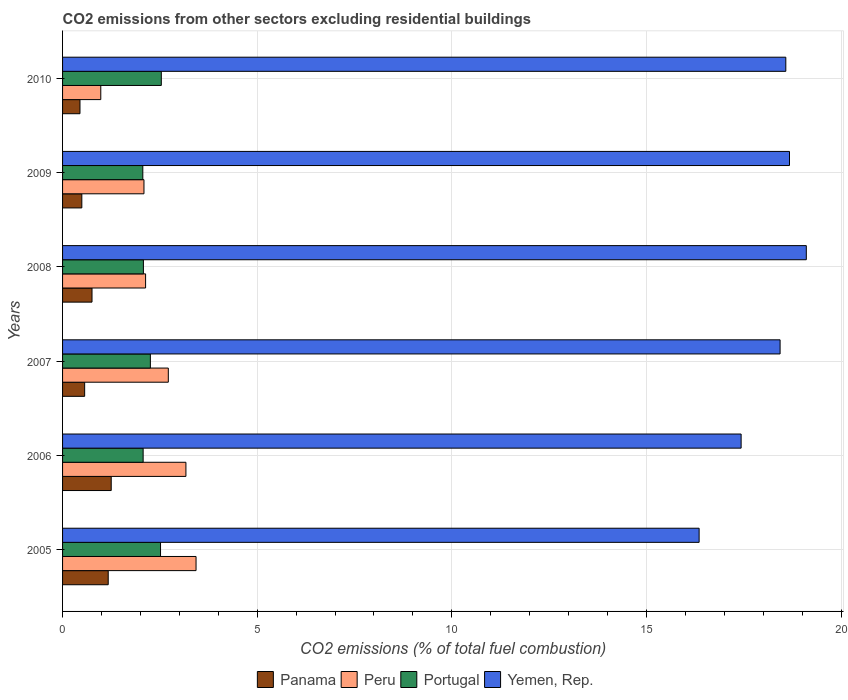How many groups of bars are there?
Ensure brevity in your answer.  6. How many bars are there on the 6th tick from the bottom?
Your answer should be compact. 4. What is the total CO2 emitted in Panama in 2006?
Provide a short and direct response. 1.25. Across all years, what is the maximum total CO2 emitted in Panama?
Your answer should be compact. 1.25. Across all years, what is the minimum total CO2 emitted in Portugal?
Give a very brief answer. 2.06. In which year was the total CO2 emitted in Yemen, Rep. minimum?
Make the answer very short. 2005. What is the total total CO2 emitted in Yemen, Rep. in the graph?
Give a very brief answer. 108.59. What is the difference between the total CO2 emitted in Yemen, Rep. in 2006 and that in 2010?
Your response must be concise. -1.15. What is the difference between the total CO2 emitted in Peru in 2006 and the total CO2 emitted in Portugal in 2010?
Offer a very short reply. 0.63. What is the average total CO2 emitted in Panama per year?
Make the answer very short. 0.78. In the year 2007, what is the difference between the total CO2 emitted in Peru and total CO2 emitted in Panama?
Your response must be concise. 2.15. What is the ratio of the total CO2 emitted in Yemen, Rep. in 2006 to that in 2010?
Your answer should be very brief. 0.94. Is the difference between the total CO2 emitted in Peru in 2007 and 2008 greater than the difference between the total CO2 emitted in Panama in 2007 and 2008?
Provide a succinct answer. Yes. What is the difference between the highest and the second highest total CO2 emitted in Portugal?
Your answer should be very brief. 0.02. What is the difference between the highest and the lowest total CO2 emitted in Portugal?
Provide a short and direct response. 0.48. Is it the case that in every year, the sum of the total CO2 emitted in Portugal and total CO2 emitted in Peru is greater than the sum of total CO2 emitted in Panama and total CO2 emitted in Yemen, Rep.?
Make the answer very short. Yes. What does the 1st bar from the top in 2010 represents?
Your answer should be very brief. Yemen, Rep. What does the 2nd bar from the bottom in 2006 represents?
Provide a short and direct response. Peru. How many bars are there?
Provide a succinct answer. 24. What is the difference between two consecutive major ticks on the X-axis?
Provide a succinct answer. 5. Does the graph contain grids?
Keep it short and to the point. Yes. How are the legend labels stacked?
Give a very brief answer. Horizontal. What is the title of the graph?
Offer a terse response. CO2 emissions from other sectors excluding residential buildings. What is the label or title of the X-axis?
Offer a very short reply. CO2 emissions (% of total fuel combustion). What is the CO2 emissions (% of total fuel combustion) in Panama in 2005?
Provide a short and direct response. 1.17. What is the CO2 emissions (% of total fuel combustion) of Peru in 2005?
Keep it short and to the point. 3.43. What is the CO2 emissions (% of total fuel combustion) in Portugal in 2005?
Make the answer very short. 2.52. What is the CO2 emissions (% of total fuel combustion) in Yemen, Rep. in 2005?
Ensure brevity in your answer.  16.35. What is the CO2 emissions (% of total fuel combustion) of Peru in 2006?
Make the answer very short. 3.17. What is the CO2 emissions (% of total fuel combustion) of Portugal in 2006?
Your answer should be compact. 2.07. What is the CO2 emissions (% of total fuel combustion) of Yemen, Rep. in 2006?
Your answer should be compact. 17.43. What is the CO2 emissions (% of total fuel combustion) of Panama in 2007?
Provide a short and direct response. 0.57. What is the CO2 emissions (% of total fuel combustion) in Peru in 2007?
Your answer should be very brief. 2.72. What is the CO2 emissions (% of total fuel combustion) of Portugal in 2007?
Keep it short and to the point. 2.26. What is the CO2 emissions (% of total fuel combustion) in Yemen, Rep. in 2007?
Make the answer very short. 18.43. What is the CO2 emissions (% of total fuel combustion) of Panama in 2008?
Provide a succinct answer. 0.76. What is the CO2 emissions (% of total fuel combustion) in Peru in 2008?
Provide a short and direct response. 2.13. What is the CO2 emissions (% of total fuel combustion) of Portugal in 2008?
Provide a succinct answer. 2.08. What is the CO2 emissions (% of total fuel combustion) in Yemen, Rep. in 2008?
Keep it short and to the point. 19.11. What is the CO2 emissions (% of total fuel combustion) of Panama in 2009?
Your answer should be very brief. 0.5. What is the CO2 emissions (% of total fuel combustion) in Peru in 2009?
Provide a succinct answer. 2.09. What is the CO2 emissions (% of total fuel combustion) in Portugal in 2009?
Keep it short and to the point. 2.06. What is the CO2 emissions (% of total fuel combustion) of Yemen, Rep. in 2009?
Your answer should be very brief. 18.68. What is the CO2 emissions (% of total fuel combustion) of Panama in 2010?
Provide a short and direct response. 0.45. What is the CO2 emissions (% of total fuel combustion) in Peru in 2010?
Your answer should be compact. 0.98. What is the CO2 emissions (% of total fuel combustion) of Portugal in 2010?
Offer a very short reply. 2.54. What is the CO2 emissions (% of total fuel combustion) of Yemen, Rep. in 2010?
Offer a terse response. 18.58. Across all years, what is the maximum CO2 emissions (% of total fuel combustion) of Peru?
Make the answer very short. 3.43. Across all years, what is the maximum CO2 emissions (% of total fuel combustion) in Portugal?
Your answer should be compact. 2.54. Across all years, what is the maximum CO2 emissions (% of total fuel combustion) in Yemen, Rep.?
Your answer should be compact. 19.11. Across all years, what is the minimum CO2 emissions (% of total fuel combustion) of Panama?
Provide a succinct answer. 0.45. Across all years, what is the minimum CO2 emissions (% of total fuel combustion) in Peru?
Ensure brevity in your answer.  0.98. Across all years, what is the minimum CO2 emissions (% of total fuel combustion) of Portugal?
Provide a short and direct response. 2.06. Across all years, what is the minimum CO2 emissions (% of total fuel combustion) in Yemen, Rep.?
Provide a succinct answer. 16.35. What is the total CO2 emissions (% of total fuel combustion) of Panama in the graph?
Ensure brevity in your answer.  4.69. What is the total CO2 emissions (% of total fuel combustion) in Peru in the graph?
Provide a short and direct response. 14.52. What is the total CO2 emissions (% of total fuel combustion) of Portugal in the graph?
Your response must be concise. 13.52. What is the total CO2 emissions (% of total fuel combustion) of Yemen, Rep. in the graph?
Offer a very short reply. 108.59. What is the difference between the CO2 emissions (% of total fuel combustion) of Panama in 2005 and that in 2006?
Make the answer very short. -0.08. What is the difference between the CO2 emissions (% of total fuel combustion) of Peru in 2005 and that in 2006?
Your response must be concise. 0.26. What is the difference between the CO2 emissions (% of total fuel combustion) of Portugal in 2005 and that in 2006?
Offer a terse response. 0.45. What is the difference between the CO2 emissions (% of total fuel combustion) of Yemen, Rep. in 2005 and that in 2006?
Your response must be concise. -1.08. What is the difference between the CO2 emissions (% of total fuel combustion) in Panama in 2005 and that in 2007?
Offer a terse response. 0.61. What is the difference between the CO2 emissions (% of total fuel combustion) of Peru in 2005 and that in 2007?
Provide a succinct answer. 0.71. What is the difference between the CO2 emissions (% of total fuel combustion) of Portugal in 2005 and that in 2007?
Provide a short and direct response. 0.26. What is the difference between the CO2 emissions (% of total fuel combustion) of Yemen, Rep. in 2005 and that in 2007?
Offer a terse response. -2.08. What is the difference between the CO2 emissions (% of total fuel combustion) of Panama in 2005 and that in 2008?
Give a very brief answer. 0.42. What is the difference between the CO2 emissions (% of total fuel combustion) of Peru in 2005 and that in 2008?
Make the answer very short. 1.3. What is the difference between the CO2 emissions (% of total fuel combustion) in Portugal in 2005 and that in 2008?
Ensure brevity in your answer.  0.44. What is the difference between the CO2 emissions (% of total fuel combustion) of Yemen, Rep. in 2005 and that in 2008?
Offer a very short reply. -2.75. What is the difference between the CO2 emissions (% of total fuel combustion) in Panama in 2005 and that in 2009?
Offer a very short reply. 0.68. What is the difference between the CO2 emissions (% of total fuel combustion) of Peru in 2005 and that in 2009?
Your response must be concise. 1.34. What is the difference between the CO2 emissions (% of total fuel combustion) of Portugal in 2005 and that in 2009?
Offer a terse response. 0.46. What is the difference between the CO2 emissions (% of total fuel combustion) of Yemen, Rep. in 2005 and that in 2009?
Ensure brevity in your answer.  -2.32. What is the difference between the CO2 emissions (% of total fuel combustion) in Panama in 2005 and that in 2010?
Offer a very short reply. 0.73. What is the difference between the CO2 emissions (% of total fuel combustion) of Peru in 2005 and that in 2010?
Provide a short and direct response. 2.45. What is the difference between the CO2 emissions (% of total fuel combustion) of Portugal in 2005 and that in 2010?
Provide a short and direct response. -0.02. What is the difference between the CO2 emissions (% of total fuel combustion) of Yemen, Rep. in 2005 and that in 2010?
Offer a terse response. -2.23. What is the difference between the CO2 emissions (% of total fuel combustion) in Panama in 2006 and that in 2007?
Your answer should be compact. 0.68. What is the difference between the CO2 emissions (% of total fuel combustion) in Peru in 2006 and that in 2007?
Give a very brief answer. 0.45. What is the difference between the CO2 emissions (% of total fuel combustion) in Portugal in 2006 and that in 2007?
Give a very brief answer. -0.19. What is the difference between the CO2 emissions (% of total fuel combustion) of Yemen, Rep. in 2006 and that in 2007?
Your response must be concise. -1. What is the difference between the CO2 emissions (% of total fuel combustion) of Panama in 2006 and that in 2008?
Ensure brevity in your answer.  0.49. What is the difference between the CO2 emissions (% of total fuel combustion) of Peru in 2006 and that in 2008?
Give a very brief answer. 1.04. What is the difference between the CO2 emissions (% of total fuel combustion) in Portugal in 2006 and that in 2008?
Give a very brief answer. -0.01. What is the difference between the CO2 emissions (% of total fuel combustion) in Yemen, Rep. in 2006 and that in 2008?
Keep it short and to the point. -1.67. What is the difference between the CO2 emissions (% of total fuel combustion) in Panama in 2006 and that in 2009?
Offer a very short reply. 0.76. What is the difference between the CO2 emissions (% of total fuel combustion) of Peru in 2006 and that in 2009?
Your answer should be compact. 1.08. What is the difference between the CO2 emissions (% of total fuel combustion) in Portugal in 2006 and that in 2009?
Make the answer very short. 0.01. What is the difference between the CO2 emissions (% of total fuel combustion) of Yemen, Rep. in 2006 and that in 2009?
Offer a terse response. -1.24. What is the difference between the CO2 emissions (% of total fuel combustion) in Panama in 2006 and that in 2010?
Offer a very short reply. 0.8. What is the difference between the CO2 emissions (% of total fuel combustion) in Peru in 2006 and that in 2010?
Your answer should be compact. 2.19. What is the difference between the CO2 emissions (% of total fuel combustion) in Portugal in 2006 and that in 2010?
Provide a succinct answer. -0.47. What is the difference between the CO2 emissions (% of total fuel combustion) of Yemen, Rep. in 2006 and that in 2010?
Offer a very short reply. -1.15. What is the difference between the CO2 emissions (% of total fuel combustion) in Panama in 2007 and that in 2008?
Provide a succinct answer. -0.19. What is the difference between the CO2 emissions (% of total fuel combustion) in Peru in 2007 and that in 2008?
Ensure brevity in your answer.  0.58. What is the difference between the CO2 emissions (% of total fuel combustion) of Portugal in 2007 and that in 2008?
Provide a succinct answer. 0.18. What is the difference between the CO2 emissions (% of total fuel combustion) in Yemen, Rep. in 2007 and that in 2008?
Your answer should be very brief. -0.67. What is the difference between the CO2 emissions (% of total fuel combustion) of Panama in 2007 and that in 2009?
Ensure brevity in your answer.  0.07. What is the difference between the CO2 emissions (% of total fuel combustion) in Peru in 2007 and that in 2009?
Your response must be concise. 0.63. What is the difference between the CO2 emissions (% of total fuel combustion) of Portugal in 2007 and that in 2009?
Offer a very short reply. 0.19. What is the difference between the CO2 emissions (% of total fuel combustion) of Yemen, Rep. in 2007 and that in 2009?
Your answer should be very brief. -0.24. What is the difference between the CO2 emissions (% of total fuel combustion) in Panama in 2007 and that in 2010?
Your response must be concise. 0.12. What is the difference between the CO2 emissions (% of total fuel combustion) in Peru in 2007 and that in 2010?
Provide a succinct answer. 1.73. What is the difference between the CO2 emissions (% of total fuel combustion) in Portugal in 2007 and that in 2010?
Provide a succinct answer. -0.28. What is the difference between the CO2 emissions (% of total fuel combustion) of Yemen, Rep. in 2007 and that in 2010?
Your answer should be compact. -0.15. What is the difference between the CO2 emissions (% of total fuel combustion) in Panama in 2008 and that in 2009?
Ensure brevity in your answer.  0.26. What is the difference between the CO2 emissions (% of total fuel combustion) in Peru in 2008 and that in 2009?
Ensure brevity in your answer.  0.04. What is the difference between the CO2 emissions (% of total fuel combustion) of Portugal in 2008 and that in 2009?
Your answer should be compact. 0.02. What is the difference between the CO2 emissions (% of total fuel combustion) in Yemen, Rep. in 2008 and that in 2009?
Keep it short and to the point. 0.43. What is the difference between the CO2 emissions (% of total fuel combustion) in Panama in 2008 and that in 2010?
Offer a terse response. 0.31. What is the difference between the CO2 emissions (% of total fuel combustion) in Peru in 2008 and that in 2010?
Your answer should be very brief. 1.15. What is the difference between the CO2 emissions (% of total fuel combustion) of Portugal in 2008 and that in 2010?
Give a very brief answer. -0.46. What is the difference between the CO2 emissions (% of total fuel combustion) in Yemen, Rep. in 2008 and that in 2010?
Keep it short and to the point. 0.53. What is the difference between the CO2 emissions (% of total fuel combustion) in Panama in 2009 and that in 2010?
Provide a succinct answer. 0.05. What is the difference between the CO2 emissions (% of total fuel combustion) of Peru in 2009 and that in 2010?
Your answer should be very brief. 1.11. What is the difference between the CO2 emissions (% of total fuel combustion) in Portugal in 2009 and that in 2010?
Provide a succinct answer. -0.48. What is the difference between the CO2 emissions (% of total fuel combustion) of Yemen, Rep. in 2009 and that in 2010?
Keep it short and to the point. 0.09. What is the difference between the CO2 emissions (% of total fuel combustion) of Panama in 2005 and the CO2 emissions (% of total fuel combustion) of Peru in 2006?
Make the answer very short. -2. What is the difference between the CO2 emissions (% of total fuel combustion) in Panama in 2005 and the CO2 emissions (% of total fuel combustion) in Portugal in 2006?
Your answer should be very brief. -0.9. What is the difference between the CO2 emissions (% of total fuel combustion) in Panama in 2005 and the CO2 emissions (% of total fuel combustion) in Yemen, Rep. in 2006?
Give a very brief answer. -16.26. What is the difference between the CO2 emissions (% of total fuel combustion) in Peru in 2005 and the CO2 emissions (% of total fuel combustion) in Portugal in 2006?
Make the answer very short. 1.36. What is the difference between the CO2 emissions (% of total fuel combustion) in Peru in 2005 and the CO2 emissions (% of total fuel combustion) in Yemen, Rep. in 2006?
Offer a very short reply. -14. What is the difference between the CO2 emissions (% of total fuel combustion) of Portugal in 2005 and the CO2 emissions (% of total fuel combustion) of Yemen, Rep. in 2006?
Your response must be concise. -14.92. What is the difference between the CO2 emissions (% of total fuel combustion) of Panama in 2005 and the CO2 emissions (% of total fuel combustion) of Peru in 2007?
Provide a succinct answer. -1.54. What is the difference between the CO2 emissions (% of total fuel combustion) of Panama in 2005 and the CO2 emissions (% of total fuel combustion) of Portugal in 2007?
Your answer should be compact. -1.08. What is the difference between the CO2 emissions (% of total fuel combustion) in Panama in 2005 and the CO2 emissions (% of total fuel combustion) in Yemen, Rep. in 2007?
Provide a succinct answer. -17.26. What is the difference between the CO2 emissions (% of total fuel combustion) in Peru in 2005 and the CO2 emissions (% of total fuel combustion) in Portugal in 2007?
Keep it short and to the point. 1.17. What is the difference between the CO2 emissions (% of total fuel combustion) in Peru in 2005 and the CO2 emissions (% of total fuel combustion) in Yemen, Rep. in 2007?
Your answer should be very brief. -15.01. What is the difference between the CO2 emissions (% of total fuel combustion) in Portugal in 2005 and the CO2 emissions (% of total fuel combustion) in Yemen, Rep. in 2007?
Give a very brief answer. -15.92. What is the difference between the CO2 emissions (% of total fuel combustion) of Panama in 2005 and the CO2 emissions (% of total fuel combustion) of Peru in 2008?
Ensure brevity in your answer.  -0.96. What is the difference between the CO2 emissions (% of total fuel combustion) of Panama in 2005 and the CO2 emissions (% of total fuel combustion) of Portugal in 2008?
Ensure brevity in your answer.  -0.9. What is the difference between the CO2 emissions (% of total fuel combustion) in Panama in 2005 and the CO2 emissions (% of total fuel combustion) in Yemen, Rep. in 2008?
Your answer should be compact. -17.93. What is the difference between the CO2 emissions (% of total fuel combustion) of Peru in 2005 and the CO2 emissions (% of total fuel combustion) of Portugal in 2008?
Your response must be concise. 1.35. What is the difference between the CO2 emissions (% of total fuel combustion) of Peru in 2005 and the CO2 emissions (% of total fuel combustion) of Yemen, Rep. in 2008?
Provide a short and direct response. -15.68. What is the difference between the CO2 emissions (% of total fuel combustion) of Portugal in 2005 and the CO2 emissions (% of total fuel combustion) of Yemen, Rep. in 2008?
Your answer should be compact. -16.59. What is the difference between the CO2 emissions (% of total fuel combustion) in Panama in 2005 and the CO2 emissions (% of total fuel combustion) in Peru in 2009?
Your answer should be compact. -0.92. What is the difference between the CO2 emissions (% of total fuel combustion) of Panama in 2005 and the CO2 emissions (% of total fuel combustion) of Portugal in 2009?
Keep it short and to the point. -0.89. What is the difference between the CO2 emissions (% of total fuel combustion) of Panama in 2005 and the CO2 emissions (% of total fuel combustion) of Yemen, Rep. in 2009?
Your answer should be compact. -17.5. What is the difference between the CO2 emissions (% of total fuel combustion) of Peru in 2005 and the CO2 emissions (% of total fuel combustion) of Portugal in 2009?
Provide a succinct answer. 1.37. What is the difference between the CO2 emissions (% of total fuel combustion) in Peru in 2005 and the CO2 emissions (% of total fuel combustion) in Yemen, Rep. in 2009?
Your response must be concise. -15.25. What is the difference between the CO2 emissions (% of total fuel combustion) of Portugal in 2005 and the CO2 emissions (% of total fuel combustion) of Yemen, Rep. in 2009?
Your answer should be very brief. -16.16. What is the difference between the CO2 emissions (% of total fuel combustion) of Panama in 2005 and the CO2 emissions (% of total fuel combustion) of Peru in 2010?
Provide a short and direct response. 0.19. What is the difference between the CO2 emissions (% of total fuel combustion) in Panama in 2005 and the CO2 emissions (% of total fuel combustion) in Portugal in 2010?
Your answer should be very brief. -1.36. What is the difference between the CO2 emissions (% of total fuel combustion) in Panama in 2005 and the CO2 emissions (% of total fuel combustion) in Yemen, Rep. in 2010?
Offer a very short reply. -17.41. What is the difference between the CO2 emissions (% of total fuel combustion) of Peru in 2005 and the CO2 emissions (% of total fuel combustion) of Portugal in 2010?
Keep it short and to the point. 0.89. What is the difference between the CO2 emissions (% of total fuel combustion) of Peru in 2005 and the CO2 emissions (% of total fuel combustion) of Yemen, Rep. in 2010?
Your answer should be very brief. -15.15. What is the difference between the CO2 emissions (% of total fuel combustion) in Portugal in 2005 and the CO2 emissions (% of total fuel combustion) in Yemen, Rep. in 2010?
Your response must be concise. -16.06. What is the difference between the CO2 emissions (% of total fuel combustion) in Panama in 2006 and the CO2 emissions (% of total fuel combustion) in Peru in 2007?
Ensure brevity in your answer.  -1.47. What is the difference between the CO2 emissions (% of total fuel combustion) in Panama in 2006 and the CO2 emissions (% of total fuel combustion) in Portugal in 2007?
Ensure brevity in your answer.  -1.01. What is the difference between the CO2 emissions (% of total fuel combustion) of Panama in 2006 and the CO2 emissions (% of total fuel combustion) of Yemen, Rep. in 2007?
Offer a terse response. -17.18. What is the difference between the CO2 emissions (% of total fuel combustion) in Peru in 2006 and the CO2 emissions (% of total fuel combustion) in Yemen, Rep. in 2007?
Your answer should be compact. -15.27. What is the difference between the CO2 emissions (% of total fuel combustion) of Portugal in 2006 and the CO2 emissions (% of total fuel combustion) of Yemen, Rep. in 2007?
Give a very brief answer. -16.36. What is the difference between the CO2 emissions (% of total fuel combustion) of Panama in 2006 and the CO2 emissions (% of total fuel combustion) of Peru in 2008?
Offer a very short reply. -0.88. What is the difference between the CO2 emissions (% of total fuel combustion) of Panama in 2006 and the CO2 emissions (% of total fuel combustion) of Portugal in 2008?
Keep it short and to the point. -0.83. What is the difference between the CO2 emissions (% of total fuel combustion) in Panama in 2006 and the CO2 emissions (% of total fuel combustion) in Yemen, Rep. in 2008?
Offer a very short reply. -17.86. What is the difference between the CO2 emissions (% of total fuel combustion) in Peru in 2006 and the CO2 emissions (% of total fuel combustion) in Portugal in 2008?
Make the answer very short. 1.09. What is the difference between the CO2 emissions (% of total fuel combustion) of Peru in 2006 and the CO2 emissions (% of total fuel combustion) of Yemen, Rep. in 2008?
Give a very brief answer. -15.94. What is the difference between the CO2 emissions (% of total fuel combustion) in Portugal in 2006 and the CO2 emissions (% of total fuel combustion) in Yemen, Rep. in 2008?
Keep it short and to the point. -17.04. What is the difference between the CO2 emissions (% of total fuel combustion) of Panama in 2006 and the CO2 emissions (% of total fuel combustion) of Peru in 2009?
Ensure brevity in your answer.  -0.84. What is the difference between the CO2 emissions (% of total fuel combustion) of Panama in 2006 and the CO2 emissions (% of total fuel combustion) of Portugal in 2009?
Offer a very short reply. -0.81. What is the difference between the CO2 emissions (% of total fuel combustion) in Panama in 2006 and the CO2 emissions (% of total fuel combustion) in Yemen, Rep. in 2009?
Your response must be concise. -17.43. What is the difference between the CO2 emissions (% of total fuel combustion) in Peru in 2006 and the CO2 emissions (% of total fuel combustion) in Portugal in 2009?
Provide a short and direct response. 1.11. What is the difference between the CO2 emissions (% of total fuel combustion) in Peru in 2006 and the CO2 emissions (% of total fuel combustion) in Yemen, Rep. in 2009?
Provide a short and direct response. -15.51. What is the difference between the CO2 emissions (% of total fuel combustion) of Portugal in 2006 and the CO2 emissions (% of total fuel combustion) of Yemen, Rep. in 2009?
Provide a succinct answer. -16.61. What is the difference between the CO2 emissions (% of total fuel combustion) of Panama in 2006 and the CO2 emissions (% of total fuel combustion) of Peru in 2010?
Offer a terse response. 0.27. What is the difference between the CO2 emissions (% of total fuel combustion) of Panama in 2006 and the CO2 emissions (% of total fuel combustion) of Portugal in 2010?
Ensure brevity in your answer.  -1.29. What is the difference between the CO2 emissions (% of total fuel combustion) of Panama in 2006 and the CO2 emissions (% of total fuel combustion) of Yemen, Rep. in 2010?
Provide a succinct answer. -17.33. What is the difference between the CO2 emissions (% of total fuel combustion) of Peru in 2006 and the CO2 emissions (% of total fuel combustion) of Portugal in 2010?
Your answer should be compact. 0.63. What is the difference between the CO2 emissions (% of total fuel combustion) in Peru in 2006 and the CO2 emissions (% of total fuel combustion) in Yemen, Rep. in 2010?
Provide a succinct answer. -15.41. What is the difference between the CO2 emissions (% of total fuel combustion) of Portugal in 2006 and the CO2 emissions (% of total fuel combustion) of Yemen, Rep. in 2010?
Provide a short and direct response. -16.51. What is the difference between the CO2 emissions (% of total fuel combustion) of Panama in 2007 and the CO2 emissions (% of total fuel combustion) of Peru in 2008?
Make the answer very short. -1.57. What is the difference between the CO2 emissions (% of total fuel combustion) of Panama in 2007 and the CO2 emissions (% of total fuel combustion) of Portugal in 2008?
Your response must be concise. -1.51. What is the difference between the CO2 emissions (% of total fuel combustion) in Panama in 2007 and the CO2 emissions (% of total fuel combustion) in Yemen, Rep. in 2008?
Provide a succinct answer. -18.54. What is the difference between the CO2 emissions (% of total fuel combustion) in Peru in 2007 and the CO2 emissions (% of total fuel combustion) in Portugal in 2008?
Your response must be concise. 0.64. What is the difference between the CO2 emissions (% of total fuel combustion) of Peru in 2007 and the CO2 emissions (% of total fuel combustion) of Yemen, Rep. in 2008?
Ensure brevity in your answer.  -16.39. What is the difference between the CO2 emissions (% of total fuel combustion) of Portugal in 2007 and the CO2 emissions (% of total fuel combustion) of Yemen, Rep. in 2008?
Your answer should be compact. -16.85. What is the difference between the CO2 emissions (% of total fuel combustion) of Panama in 2007 and the CO2 emissions (% of total fuel combustion) of Peru in 2009?
Offer a very short reply. -1.52. What is the difference between the CO2 emissions (% of total fuel combustion) of Panama in 2007 and the CO2 emissions (% of total fuel combustion) of Portugal in 2009?
Your response must be concise. -1.49. What is the difference between the CO2 emissions (% of total fuel combustion) in Panama in 2007 and the CO2 emissions (% of total fuel combustion) in Yemen, Rep. in 2009?
Your answer should be compact. -18.11. What is the difference between the CO2 emissions (% of total fuel combustion) of Peru in 2007 and the CO2 emissions (% of total fuel combustion) of Portugal in 2009?
Offer a very short reply. 0.66. What is the difference between the CO2 emissions (% of total fuel combustion) in Peru in 2007 and the CO2 emissions (% of total fuel combustion) in Yemen, Rep. in 2009?
Give a very brief answer. -15.96. What is the difference between the CO2 emissions (% of total fuel combustion) of Portugal in 2007 and the CO2 emissions (% of total fuel combustion) of Yemen, Rep. in 2009?
Offer a terse response. -16.42. What is the difference between the CO2 emissions (% of total fuel combustion) in Panama in 2007 and the CO2 emissions (% of total fuel combustion) in Peru in 2010?
Make the answer very short. -0.41. What is the difference between the CO2 emissions (% of total fuel combustion) in Panama in 2007 and the CO2 emissions (% of total fuel combustion) in Portugal in 2010?
Offer a very short reply. -1.97. What is the difference between the CO2 emissions (% of total fuel combustion) in Panama in 2007 and the CO2 emissions (% of total fuel combustion) in Yemen, Rep. in 2010?
Offer a very short reply. -18.01. What is the difference between the CO2 emissions (% of total fuel combustion) of Peru in 2007 and the CO2 emissions (% of total fuel combustion) of Portugal in 2010?
Make the answer very short. 0.18. What is the difference between the CO2 emissions (% of total fuel combustion) in Peru in 2007 and the CO2 emissions (% of total fuel combustion) in Yemen, Rep. in 2010?
Ensure brevity in your answer.  -15.86. What is the difference between the CO2 emissions (% of total fuel combustion) of Portugal in 2007 and the CO2 emissions (% of total fuel combustion) of Yemen, Rep. in 2010?
Provide a short and direct response. -16.32. What is the difference between the CO2 emissions (% of total fuel combustion) in Panama in 2008 and the CO2 emissions (% of total fuel combustion) in Peru in 2009?
Your answer should be compact. -1.34. What is the difference between the CO2 emissions (% of total fuel combustion) of Panama in 2008 and the CO2 emissions (% of total fuel combustion) of Portugal in 2009?
Ensure brevity in your answer.  -1.3. What is the difference between the CO2 emissions (% of total fuel combustion) of Panama in 2008 and the CO2 emissions (% of total fuel combustion) of Yemen, Rep. in 2009?
Provide a short and direct response. -17.92. What is the difference between the CO2 emissions (% of total fuel combustion) in Peru in 2008 and the CO2 emissions (% of total fuel combustion) in Portugal in 2009?
Your answer should be very brief. 0.07. What is the difference between the CO2 emissions (% of total fuel combustion) in Peru in 2008 and the CO2 emissions (% of total fuel combustion) in Yemen, Rep. in 2009?
Offer a terse response. -16.54. What is the difference between the CO2 emissions (% of total fuel combustion) in Portugal in 2008 and the CO2 emissions (% of total fuel combustion) in Yemen, Rep. in 2009?
Provide a succinct answer. -16.6. What is the difference between the CO2 emissions (% of total fuel combustion) in Panama in 2008 and the CO2 emissions (% of total fuel combustion) in Peru in 2010?
Your answer should be very brief. -0.23. What is the difference between the CO2 emissions (% of total fuel combustion) of Panama in 2008 and the CO2 emissions (% of total fuel combustion) of Portugal in 2010?
Ensure brevity in your answer.  -1.78. What is the difference between the CO2 emissions (% of total fuel combustion) of Panama in 2008 and the CO2 emissions (% of total fuel combustion) of Yemen, Rep. in 2010?
Make the answer very short. -17.82. What is the difference between the CO2 emissions (% of total fuel combustion) in Peru in 2008 and the CO2 emissions (% of total fuel combustion) in Portugal in 2010?
Your answer should be very brief. -0.4. What is the difference between the CO2 emissions (% of total fuel combustion) in Peru in 2008 and the CO2 emissions (% of total fuel combustion) in Yemen, Rep. in 2010?
Give a very brief answer. -16.45. What is the difference between the CO2 emissions (% of total fuel combustion) of Portugal in 2008 and the CO2 emissions (% of total fuel combustion) of Yemen, Rep. in 2010?
Offer a terse response. -16.5. What is the difference between the CO2 emissions (% of total fuel combustion) in Panama in 2009 and the CO2 emissions (% of total fuel combustion) in Peru in 2010?
Your response must be concise. -0.49. What is the difference between the CO2 emissions (% of total fuel combustion) in Panama in 2009 and the CO2 emissions (% of total fuel combustion) in Portugal in 2010?
Offer a terse response. -2.04. What is the difference between the CO2 emissions (% of total fuel combustion) in Panama in 2009 and the CO2 emissions (% of total fuel combustion) in Yemen, Rep. in 2010?
Provide a succinct answer. -18.09. What is the difference between the CO2 emissions (% of total fuel combustion) of Peru in 2009 and the CO2 emissions (% of total fuel combustion) of Portugal in 2010?
Give a very brief answer. -0.45. What is the difference between the CO2 emissions (% of total fuel combustion) in Peru in 2009 and the CO2 emissions (% of total fuel combustion) in Yemen, Rep. in 2010?
Offer a terse response. -16.49. What is the difference between the CO2 emissions (% of total fuel combustion) in Portugal in 2009 and the CO2 emissions (% of total fuel combustion) in Yemen, Rep. in 2010?
Your answer should be very brief. -16.52. What is the average CO2 emissions (% of total fuel combustion) in Panama per year?
Your response must be concise. 0.78. What is the average CO2 emissions (% of total fuel combustion) of Peru per year?
Make the answer very short. 2.42. What is the average CO2 emissions (% of total fuel combustion) in Portugal per year?
Offer a terse response. 2.25. What is the average CO2 emissions (% of total fuel combustion) in Yemen, Rep. per year?
Your response must be concise. 18.1. In the year 2005, what is the difference between the CO2 emissions (% of total fuel combustion) in Panama and CO2 emissions (% of total fuel combustion) in Peru?
Provide a short and direct response. -2.26. In the year 2005, what is the difference between the CO2 emissions (% of total fuel combustion) of Panama and CO2 emissions (% of total fuel combustion) of Portugal?
Provide a succinct answer. -1.34. In the year 2005, what is the difference between the CO2 emissions (% of total fuel combustion) of Panama and CO2 emissions (% of total fuel combustion) of Yemen, Rep.?
Provide a succinct answer. -15.18. In the year 2005, what is the difference between the CO2 emissions (% of total fuel combustion) of Peru and CO2 emissions (% of total fuel combustion) of Portugal?
Provide a short and direct response. 0.91. In the year 2005, what is the difference between the CO2 emissions (% of total fuel combustion) in Peru and CO2 emissions (% of total fuel combustion) in Yemen, Rep.?
Keep it short and to the point. -12.92. In the year 2005, what is the difference between the CO2 emissions (% of total fuel combustion) in Portugal and CO2 emissions (% of total fuel combustion) in Yemen, Rep.?
Offer a terse response. -13.84. In the year 2006, what is the difference between the CO2 emissions (% of total fuel combustion) in Panama and CO2 emissions (% of total fuel combustion) in Peru?
Your answer should be very brief. -1.92. In the year 2006, what is the difference between the CO2 emissions (% of total fuel combustion) of Panama and CO2 emissions (% of total fuel combustion) of Portugal?
Offer a terse response. -0.82. In the year 2006, what is the difference between the CO2 emissions (% of total fuel combustion) of Panama and CO2 emissions (% of total fuel combustion) of Yemen, Rep.?
Your answer should be very brief. -16.18. In the year 2006, what is the difference between the CO2 emissions (% of total fuel combustion) in Peru and CO2 emissions (% of total fuel combustion) in Portugal?
Keep it short and to the point. 1.1. In the year 2006, what is the difference between the CO2 emissions (% of total fuel combustion) in Peru and CO2 emissions (% of total fuel combustion) in Yemen, Rep.?
Keep it short and to the point. -14.26. In the year 2006, what is the difference between the CO2 emissions (% of total fuel combustion) of Portugal and CO2 emissions (% of total fuel combustion) of Yemen, Rep.?
Provide a short and direct response. -15.36. In the year 2007, what is the difference between the CO2 emissions (% of total fuel combustion) of Panama and CO2 emissions (% of total fuel combustion) of Peru?
Offer a very short reply. -2.15. In the year 2007, what is the difference between the CO2 emissions (% of total fuel combustion) of Panama and CO2 emissions (% of total fuel combustion) of Portugal?
Your response must be concise. -1.69. In the year 2007, what is the difference between the CO2 emissions (% of total fuel combustion) of Panama and CO2 emissions (% of total fuel combustion) of Yemen, Rep.?
Offer a very short reply. -17.87. In the year 2007, what is the difference between the CO2 emissions (% of total fuel combustion) of Peru and CO2 emissions (% of total fuel combustion) of Portugal?
Ensure brevity in your answer.  0.46. In the year 2007, what is the difference between the CO2 emissions (% of total fuel combustion) of Peru and CO2 emissions (% of total fuel combustion) of Yemen, Rep.?
Keep it short and to the point. -15.72. In the year 2007, what is the difference between the CO2 emissions (% of total fuel combustion) in Portugal and CO2 emissions (% of total fuel combustion) in Yemen, Rep.?
Give a very brief answer. -16.18. In the year 2008, what is the difference between the CO2 emissions (% of total fuel combustion) of Panama and CO2 emissions (% of total fuel combustion) of Peru?
Offer a terse response. -1.38. In the year 2008, what is the difference between the CO2 emissions (% of total fuel combustion) of Panama and CO2 emissions (% of total fuel combustion) of Portugal?
Keep it short and to the point. -1.32. In the year 2008, what is the difference between the CO2 emissions (% of total fuel combustion) of Panama and CO2 emissions (% of total fuel combustion) of Yemen, Rep.?
Your answer should be compact. -18.35. In the year 2008, what is the difference between the CO2 emissions (% of total fuel combustion) in Peru and CO2 emissions (% of total fuel combustion) in Portugal?
Keep it short and to the point. 0.06. In the year 2008, what is the difference between the CO2 emissions (% of total fuel combustion) of Peru and CO2 emissions (% of total fuel combustion) of Yemen, Rep.?
Offer a terse response. -16.97. In the year 2008, what is the difference between the CO2 emissions (% of total fuel combustion) in Portugal and CO2 emissions (% of total fuel combustion) in Yemen, Rep.?
Your response must be concise. -17.03. In the year 2009, what is the difference between the CO2 emissions (% of total fuel combustion) of Panama and CO2 emissions (% of total fuel combustion) of Peru?
Make the answer very short. -1.6. In the year 2009, what is the difference between the CO2 emissions (% of total fuel combustion) in Panama and CO2 emissions (% of total fuel combustion) in Portugal?
Ensure brevity in your answer.  -1.57. In the year 2009, what is the difference between the CO2 emissions (% of total fuel combustion) in Panama and CO2 emissions (% of total fuel combustion) in Yemen, Rep.?
Your answer should be very brief. -18.18. In the year 2009, what is the difference between the CO2 emissions (% of total fuel combustion) of Peru and CO2 emissions (% of total fuel combustion) of Portugal?
Keep it short and to the point. 0.03. In the year 2009, what is the difference between the CO2 emissions (% of total fuel combustion) in Peru and CO2 emissions (% of total fuel combustion) in Yemen, Rep.?
Provide a succinct answer. -16.58. In the year 2009, what is the difference between the CO2 emissions (% of total fuel combustion) in Portugal and CO2 emissions (% of total fuel combustion) in Yemen, Rep.?
Provide a succinct answer. -16.61. In the year 2010, what is the difference between the CO2 emissions (% of total fuel combustion) in Panama and CO2 emissions (% of total fuel combustion) in Peru?
Offer a very short reply. -0.53. In the year 2010, what is the difference between the CO2 emissions (% of total fuel combustion) in Panama and CO2 emissions (% of total fuel combustion) in Portugal?
Offer a terse response. -2.09. In the year 2010, what is the difference between the CO2 emissions (% of total fuel combustion) in Panama and CO2 emissions (% of total fuel combustion) in Yemen, Rep.?
Provide a short and direct response. -18.13. In the year 2010, what is the difference between the CO2 emissions (% of total fuel combustion) of Peru and CO2 emissions (% of total fuel combustion) of Portugal?
Offer a very short reply. -1.56. In the year 2010, what is the difference between the CO2 emissions (% of total fuel combustion) in Peru and CO2 emissions (% of total fuel combustion) in Yemen, Rep.?
Offer a terse response. -17.6. In the year 2010, what is the difference between the CO2 emissions (% of total fuel combustion) in Portugal and CO2 emissions (% of total fuel combustion) in Yemen, Rep.?
Provide a short and direct response. -16.04. What is the ratio of the CO2 emissions (% of total fuel combustion) in Panama in 2005 to that in 2006?
Provide a short and direct response. 0.94. What is the ratio of the CO2 emissions (% of total fuel combustion) of Peru in 2005 to that in 2006?
Provide a short and direct response. 1.08. What is the ratio of the CO2 emissions (% of total fuel combustion) of Portugal in 2005 to that in 2006?
Your response must be concise. 1.22. What is the ratio of the CO2 emissions (% of total fuel combustion) of Yemen, Rep. in 2005 to that in 2006?
Give a very brief answer. 0.94. What is the ratio of the CO2 emissions (% of total fuel combustion) in Panama in 2005 to that in 2007?
Keep it short and to the point. 2.07. What is the ratio of the CO2 emissions (% of total fuel combustion) of Peru in 2005 to that in 2007?
Your answer should be very brief. 1.26. What is the ratio of the CO2 emissions (% of total fuel combustion) in Portugal in 2005 to that in 2007?
Provide a short and direct response. 1.12. What is the ratio of the CO2 emissions (% of total fuel combustion) of Yemen, Rep. in 2005 to that in 2007?
Offer a very short reply. 0.89. What is the ratio of the CO2 emissions (% of total fuel combustion) of Panama in 2005 to that in 2008?
Ensure brevity in your answer.  1.55. What is the ratio of the CO2 emissions (% of total fuel combustion) in Peru in 2005 to that in 2008?
Make the answer very short. 1.61. What is the ratio of the CO2 emissions (% of total fuel combustion) in Portugal in 2005 to that in 2008?
Your answer should be very brief. 1.21. What is the ratio of the CO2 emissions (% of total fuel combustion) in Yemen, Rep. in 2005 to that in 2008?
Offer a terse response. 0.86. What is the ratio of the CO2 emissions (% of total fuel combustion) of Panama in 2005 to that in 2009?
Keep it short and to the point. 2.37. What is the ratio of the CO2 emissions (% of total fuel combustion) in Peru in 2005 to that in 2009?
Ensure brevity in your answer.  1.64. What is the ratio of the CO2 emissions (% of total fuel combustion) of Portugal in 2005 to that in 2009?
Your answer should be very brief. 1.22. What is the ratio of the CO2 emissions (% of total fuel combustion) of Yemen, Rep. in 2005 to that in 2009?
Your response must be concise. 0.88. What is the ratio of the CO2 emissions (% of total fuel combustion) of Panama in 2005 to that in 2010?
Your answer should be very brief. 2.62. What is the ratio of the CO2 emissions (% of total fuel combustion) in Peru in 2005 to that in 2010?
Keep it short and to the point. 3.49. What is the ratio of the CO2 emissions (% of total fuel combustion) of Yemen, Rep. in 2005 to that in 2010?
Give a very brief answer. 0.88. What is the ratio of the CO2 emissions (% of total fuel combustion) of Panama in 2006 to that in 2007?
Your response must be concise. 2.2. What is the ratio of the CO2 emissions (% of total fuel combustion) in Peru in 2006 to that in 2007?
Your response must be concise. 1.17. What is the ratio of the CO2 emissions (% of total fuel combustion) of Portugal in 2006 to that in 2007?
Make the answer very short. 0.92. What is the ratio of the CO2 emissions (% of total fuel combustion) of Yemen, Rep. in 2006 to that in 2007?
Provide a short and direct response. 0.95. What is the ratio of the CO2 emissions (% of total fuel combustion) in Panama in 2006 to that in 2008?
Make the answer very short. 1.65. What is the ratio of the CO2 emissions (% of total fuel combustion) in Peru in 2006 to that in 2008?
Provide a succinct answer. 1.49. What is the ratio of the CO2 emissions (% of total fuel combustion) in Yemen, Rep. in 2006 to that in 2008?
Make the answer very short. 0.91. What is the ratio of the CO2 emissions (% of total fuel combustion) in Panama in 2006 to that in 2009?
Offer a very short reply. 2.52. What is the ratio of the CO2 emissions (% of total fuel combustion) in Peru in 2006 to that in 2009?
Give a very brief answer. 1.52. What is the ratio of the CO2 emissions (% of total fuel combustion) in Portugal in 2006 to that in 2009?
Your response must be concise. 1. What is the ratio of the CO2 emissions (% of total fuel combustion) in Yemen, Rep. in 2006 to that in 2009?
Provide a short and direct response. 0.93. What is the ratio of the CO2 emissions (% of total fuel combustion) of Panama in 2006 to that in 2010?
Give a very brief answer. 2.79. What is the ratio of the CO2 emissions (% of total fuel combustion) of Peru in 2006 to that in 2010?
Keep it short and to the point. 3.23. What is the ratio of the CO2 emissions (% of total fuel combustion) of Portugal in 2006 to that in 2010?
Provide a succinct answer. 0.82. What is the ratio of the CO2 emissions (% of total fuel combustion) of Yemen, Rep. in 2006 to that in 2010?
Make the answer very short. 0.94. What is the ratio of the CO2 emissions (% of total fuel combustion) of Panama in 2007 to that in 2008?
Offer a terse response. 0.75. What is the ratio of the CO2 emissions (% of total fuel combustion) in Peru in 2007 to that in 2008?
Ensure brevity in your answer.  1.27. What is the ratio of the CO2 emissions (% of total fuel combustion) in Portugal in 2007 to that in 2008?
Offer a very short reply. 1.09. What is the ratio of the CO2 emissions (% of total fuel combustion) of Yemen, Rep. in 2007 to that in 2008?
Make the answer very short. 0.96. What is the ratio of the CO2 emissions (% of total fuel combustion) of Panama in 2007 to that in 2009?
Make the answer very short. 1.15. What is the ratio of the CO2 emissions (% of total fuel combustion) of Peru in 2007 to that in 2009?
Provide a succinct answer. 1.3. What is the ratio of the CO2 emissions (% of total fuel combustion) of Portugal in 2007 to that in 2009?
Ensure brevity in your answer.  1.09. What is the ratio of the CO2 emissions (% of total fuel combustion) in Yemen, Rep. in 2007 to that in 2009?
Your answer should be very brief. 0.99. What is the ratio of the CO2 emissions (% of total fuel combustion) of Panama in 2007 to that in 2010?
Offer a very short reply. 1.27. What is the ratio of the CO2 emissions (% of total fuel combustion) in Peru in 2007 to that in 2010?
Your answer should be compact. 2.77. What is the ratio of the CO2 emissions (% of total fuel combustion) in Portugal in 2007 to that in 2010?
Your response must be concise. 0.89. What is the ratio of the CO2 emissions (% of total fuel combustion) of Panama in 2008 to that in 2009?
Ensure brevity in your answer.  1.53. What is the ratio of the CO2 emissions (% of total fuel combustion) in Peru in 2008 to that in 2009?
Make the answer very short. 1.02. What is the ratio of the CO2 emissions (% of total fuel combustion) in Portugal in 2008 to that in 2009?
Keep it short and to the point. 1.01. What is the ratio of the CO2 emissions (% of total fuel combustion) of Yemen, Rep. in 2008 to that in 2009?
Offer a very short reply. 1.02. What is the ratio of the CO2 emissions (% of total fuel combustion) in Panama in 2008 to that in 2010?
Offer a very short reply. 1.69. What is the ratio of the CO2 emissions (% of total fuel combustion) of Peru in 2008 to that in 2010?
Offer a terse response. 2.17. What is the ratio of the CO2 emissions (% of total fuel combustion) in Portugal in 2008 to that in 2010?
Provide a short and direct response. 0.82. What is the ratio of the CO2 emissions (% of total fuel combustion) of Yemen, Rep. in 2008 to that in 2010?
Make the answer very short. 1.03. What is the ratio of the CO2 emissions (% of total fuel combustion) in Panama in 2009 to that in 2010?
Ensure brevity in your answer.  1.11. What is the ratio of the CO2 emissions (% of total fuel combustion) of Peru in 2009 to that in 2010?
Provide a succinct answer. 2.13. What is the ratio of the CO2 emissions (% of total fuel combustion) of Portugal in 2009 to that in 2010?
Keep it short and to the point. 0.81. What is the ratio of the CO2 emissions (% of total fuel combustion) of Yemen, Rep. in 2009 to that in 2010?
Your response must be concise. 1.01. What is the difference between the highest and the second highest CO2 emissions (% of total fuel combustion) in Panama?
Your answer should be very brief. 0.08. What is the difference between the highest and the second highest CO2 emissions (% of total fuel combustion) of Peru?
Provide a short and direct response. 0.26. What is the difference between the highest and the second highest CO2 emissions (% of total fuel combustion) in Portugal?
Keep it short and to the point. 0.02. What is the difference between the highest and the second highest CO2 emissions (% of total fuel combustion) of Yemen, Rep.?
Keep it short and to the point. 0.43. What is the difference between the highest and the lowest CO2 emissions (% of total fuel combustion) in Panama?
Ensure brevity in your answer.  0.8. What is the difference between the highest and the lowest CO2 emissions (% of total fuel combustion) of Peru?
Your response must be concise. 2.45. What is the difference between the highest and the lowest CO2 emissions (% of total fuel combustion) of Portugal?
Ensure brevity in your answer.  0.48. What is the difference between the highest and the lowest CO2 emissions (% of total fuel combustion) of Yemen, Rep.?
Offer a very short reply. 2.75. 